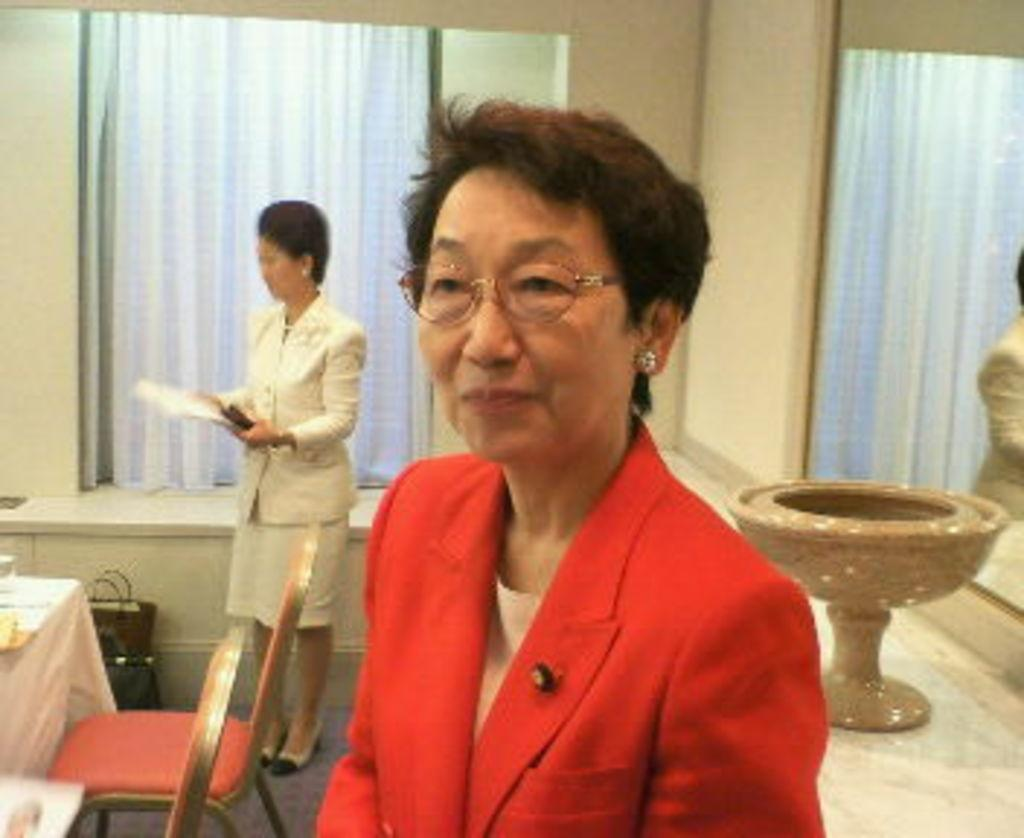What is the woman in the image doing? The woman is posing for the camera. What is the woman wearing in the image? The woman is wearing a red-colored suit. What furniture can be seen in the image? There are chairs and a table in the image. Can you describe the presence of other people in the image? There is another woman in the background of the image. What type of bomb is being painted with thread in the image? There is no bomb, paint, or thread present in the image. 